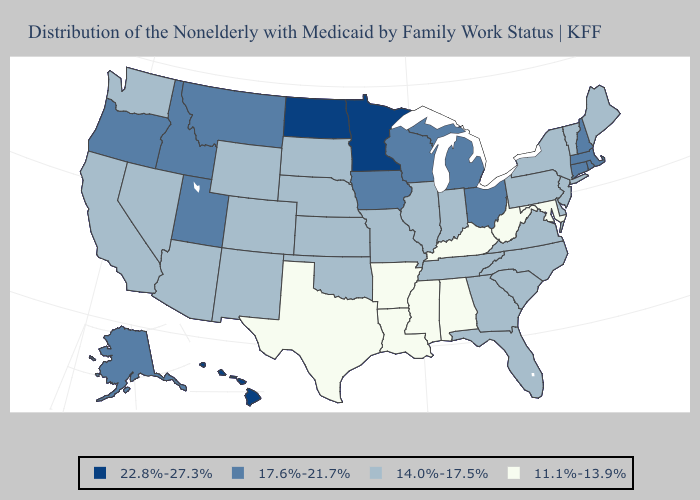Does Montana have the highest value in the West?
Short answer required. No. Among the states that border Michigan , which have the lowest value?
Quick response, please. Indiana. Name the states that have a value in the range 17.6%-21.7%?
Quick response, please. Alaska, Connecticut, Idaho, Iowa, Massachusetts, Michigan, Montana, New Hampshire, Ohio, Oregon, Rhode Island, Utah, Wisconsin. Does Kentucky have the lowest value in the South?
Write a very short answer. Yes. Name the states that have a value in the range 22.8%-27.3%?
Answer briefly. Hawaii, Minnesota, North Dakota. Does California have a lower value than Ohio?
Answer briefly. Yes. Among the states that border Pennsylvania , does Ohio have the lowest value?
Give a very brief answer. No. Among the states that border Minnesota , which have the highest value?
Quick response, please. North Dakota. Does Minnesota have the highest value in the USA?
Be succinct. Yes. Does New Mexico have the lowest value in the USA?
Concise answer only. No. What is the value of New Jersey?
Answer briefly. 14.0%-17.5%. What is the highest value in states that border Indiana?
Short answer required. 17.6%-21.7%. Does Minnesota have the highest value in the USA?
Give a very brief answer. Yes. How many symbols are there in the legend?
Quick response, please. 4. 